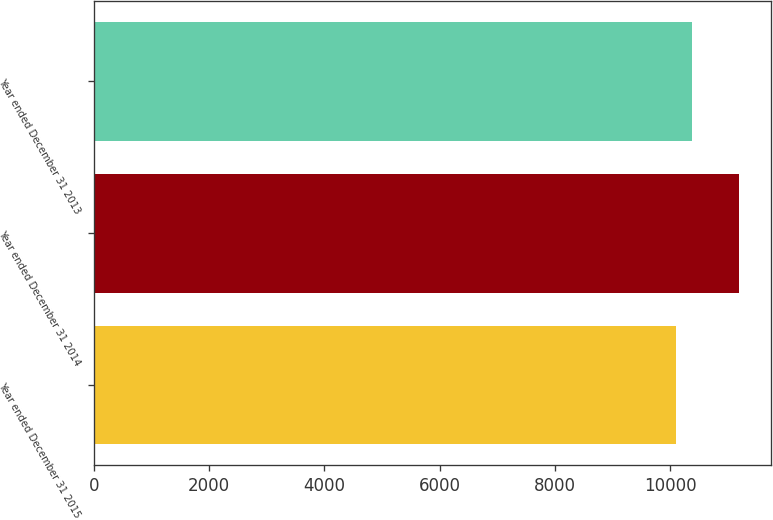<chart> <loc_0><loc_0><loc_500><loc_500><bar_chart><fcel>Year ended December 31 2015<fcel>Year ended December 31 2014<fcel>Year ended December 31 2013<nl><fcel>10113<fcel>11197<fcel>10388<nl></chart> 